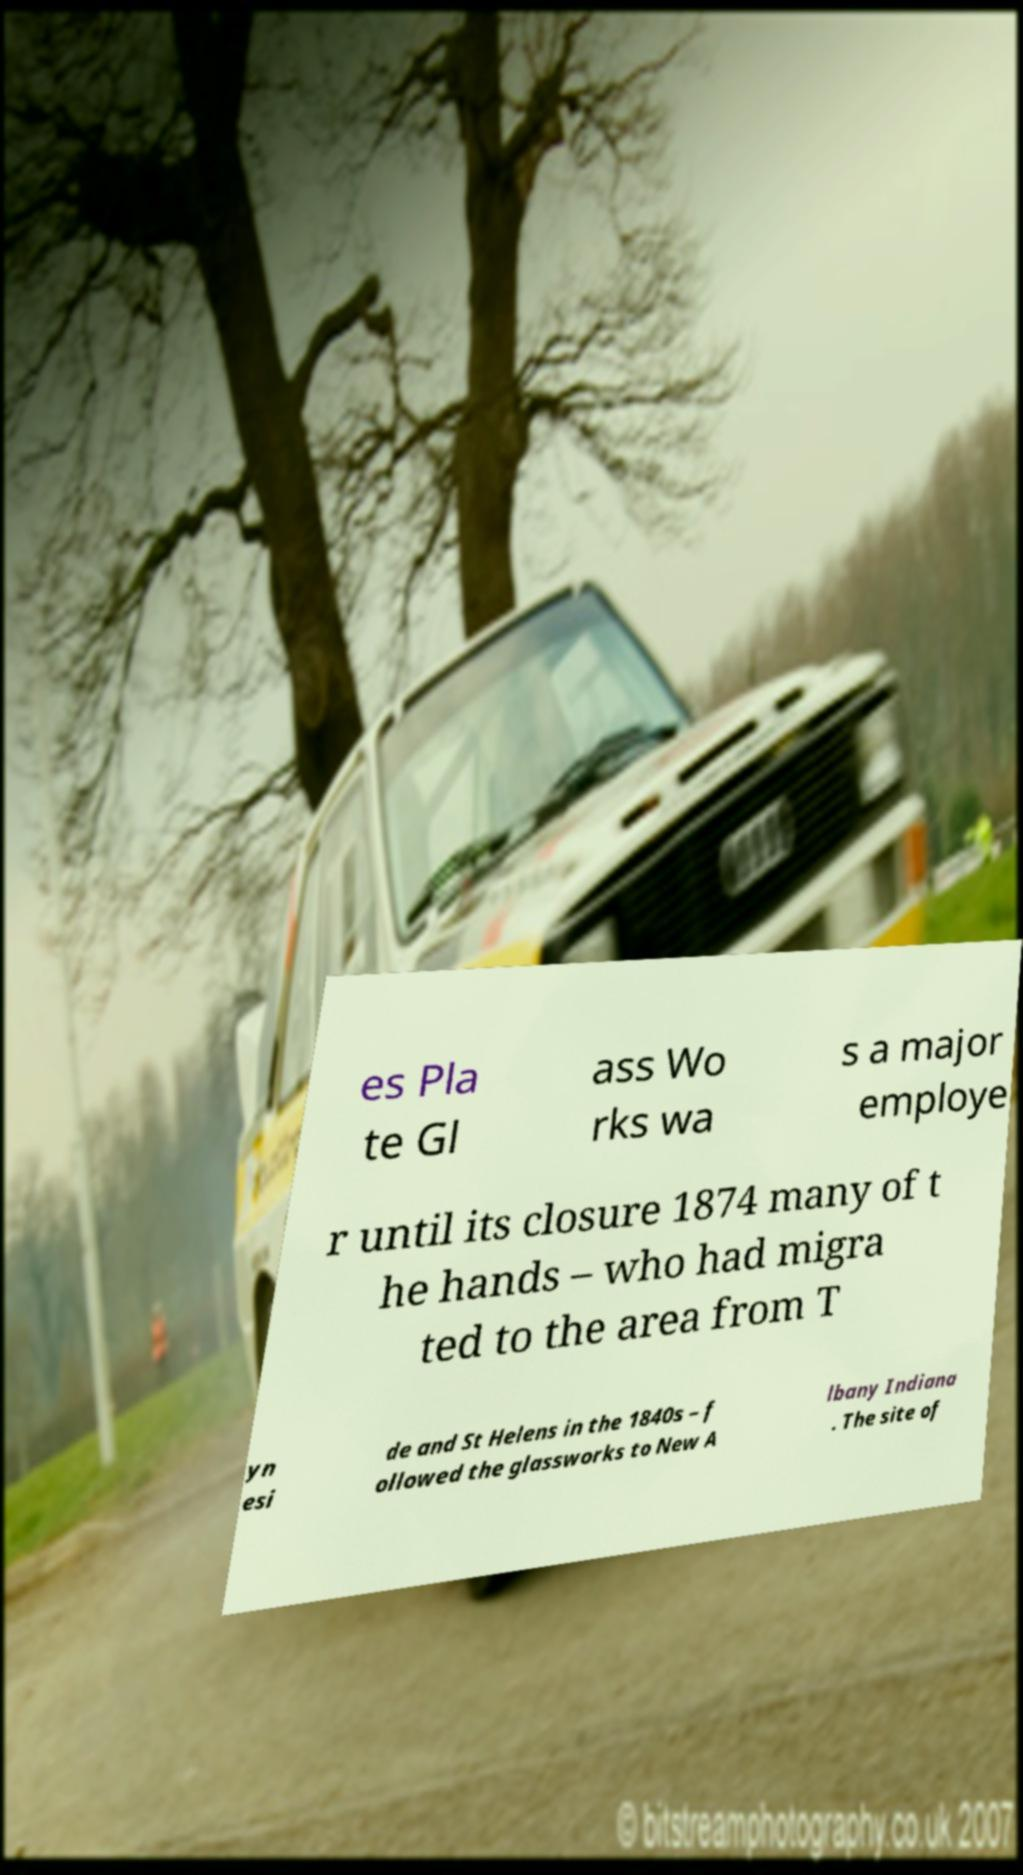Can you read and provide the text displayed in the image?This photo seems to have some interesting text. Can you extract and type it out for me? es Pla te Gl ass Wo rks wa s a major employe r until its closure 1874 many of t he hands – who had migra ted to the area from T yn esi de and St Helens in the 1840s – f ollowed the glassworks to New A lbany Indiana . The site of 